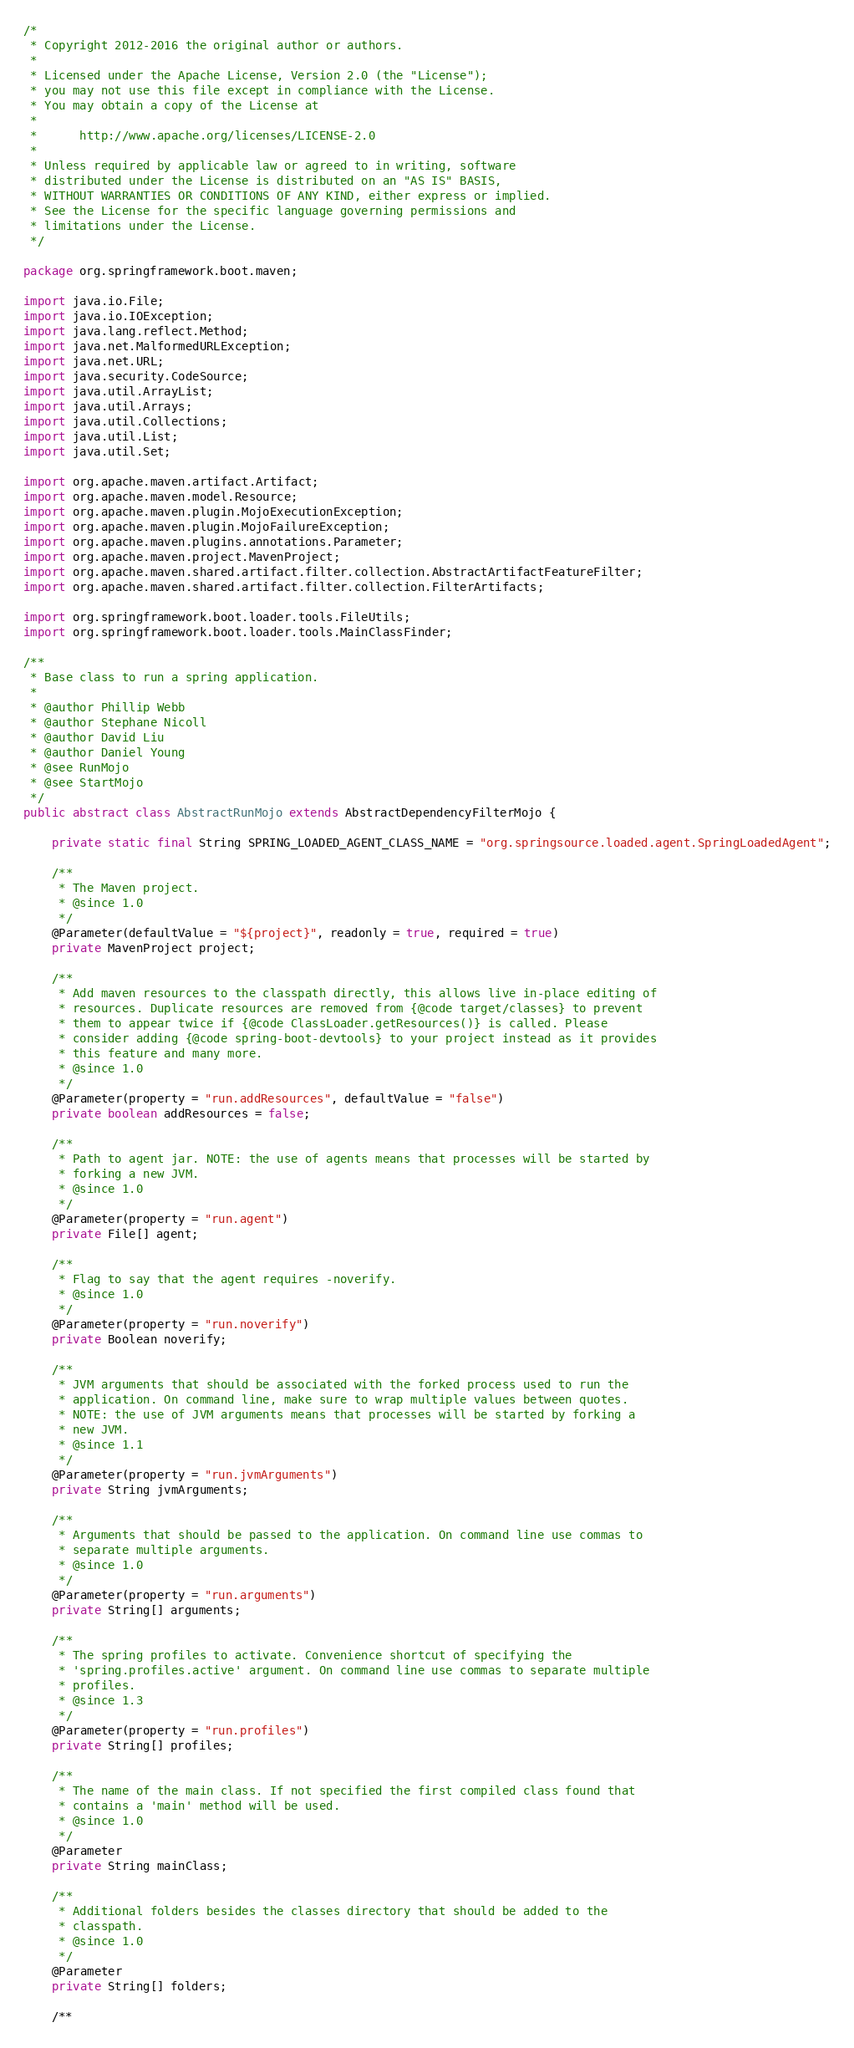Convert code to text. <code><loc_0><loc_0><loc_500><loc_500><_Java_>/*
 * Copyright 2012-2016 the original author or authors.
 *
 * Licensed under the Apache License, Version 2.0 (the "License");
 * you may not use this file except in compliance with the License.
 * You may obtain a copy of the License at
 *
 *      http://www.apache.org/licenses/LICENSE-2.0
 *
 * Unless required by applicable law or agreed to in writing, software
 * distributed under the License is distributed on an "AS IS" BASIS,
 * WITHOUT WARRANTIES OR CONDITIONS OF ANY KIND, either express or implied.
 * See the License for the specific language governing permissions and
 * limitations under the License.
 */

package org.springframework.boot.maven;

import java.io.File;
import java.io.IOException;
import java.lang.reflect.Method;
import java.net.MalformedURLException;
import java.net.URL;
import java.security.CodeSource;
import java.util.ArrayList;
import java.util.Arrays;
import java.util.Collections;
import java.util.List;
import java.util.Set;

import org.apache.maven.artifact.Artifact;
import org.apache.maven.model.Resource;
import org.apache.maven.plugin.MojoExecutionException;
import org.apache.maven.plugin.MojoFailureException;
import org.apache.maven.plugins.annotations.Parameter;
import org.apache.maven.project.MavenProject;
import org.apache.maven.shared.artifact.filter.collection.AbstractArtifactFeatureFilter;
import org.apache.maven.shared.artifact.filter.collection.FilterArtifacts;

import org.springframework.boot.loader.tools.FileUtils;
import org.springframework.boot.loader.tools.MainClassFinder;

/**
 * Base class to run a spring application.
 *
 * @author Phillip Webb
 * @author Stephane Nicoll
 * @author David Liu
 * @author Daniel Young
 * @see RunMojo
 * @see StartMojo
 */
public abstract class AbstractRunMojo extends AbstractDependencyFilterMojo {

	private static final String SPRING_LOADED_AGENT_CLASS_NAME = "org.springsource.loaded.agent.SpringLoadedAgent";

	/**
	 * The Maven project.
	 * @since 1.0
	 */
	@Parameter(defaultValue = "${project}", readonly = true, required = true)
	private MavenProject project;

	/**
	 * Add maven resources to the classpath directly, this allows live in-place editing of
	 * resources. Duplicate resources are removed from {@code target/classes} to prevent
	 * them to appear twice if {@code ClassLoader.getResources()} is called. Please
	 * consider adding {@code spring-boot-devtools} to your project instead as it provides
	 * this feature and many more.
	 * @since 1.0
	 */
	@Parameter(property = "run.addResources", defaultValue = "false")
	private boolean addResources = false;

	/**
	 * Path to agent jar. NOTE: the use of agents means that processes will be started by
	 * forking a new JVM.
	 * @since 1.0
	 */
	@Parameter(property = "run.agent")
	private File[] agent;

	/**
	 * Flag to say that the agent requires -noverify.
	 * @since 1.0
	 */
	@Parameter(property = "run.noverify")
	private Boolean noverify;

	/**
	 * JVM arguments that should be associated with the forked process used to run the
	 * application. On command line, make sure to wrap multiple values between quotes.
	 * NOTE: the use of JVM arguments means that processes will be started by forking a
	 * new JVM.
	 * @since 1.1
	 */
	@Parameter(property = "run.jvmArguments")
	private String jvmArguments;

	/**
	 * Arguments that should be passed to the application. On command line use commas to
	 * separate multiple arguments.
	 * @since 1.0
	 */
	@Parameter(property = "run.arguments")
	private String[] arguments;

	/**
	 * The spring profiles to activate. Convenience shortcut of specifying the
	 * 'spring.profiles.active' argument. On command line use commas to separate multiple
	 * profiles.
	 * @since 1.3
	 */
	@Parameter(property = "run.profiles")
	private String[] profiles;

	/**
	 * The name of the main class. If not specified the first compiled class found that
	 * contains a 'main' method will be used.
	 * @since 1.0
	 */
	@Parameter
	private String mainClass;

	/**
	 * Additional folders besides the classes directory that should be added to the
	 * classpath.
	 * @since 1.0
	 */
	@Parameter
	private String[] folders;

	/**</code> 